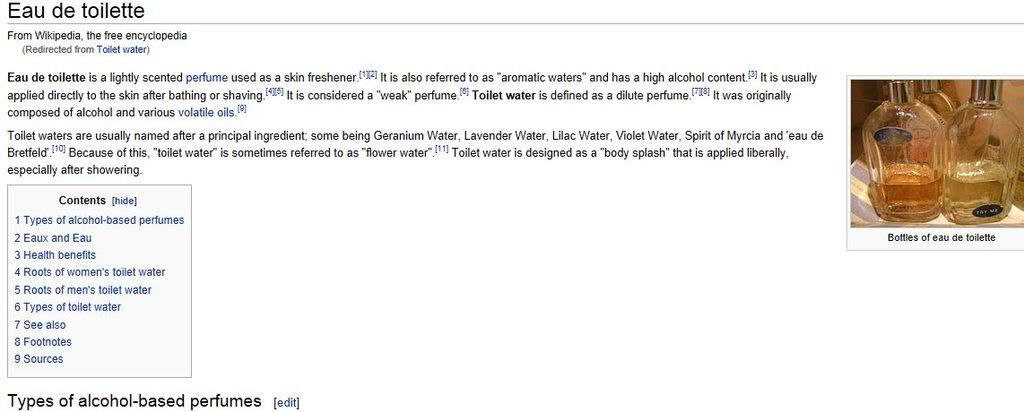<image>
Relay a brief, clear account of the picture shown. A description of Eau de toilette from wikipedia 